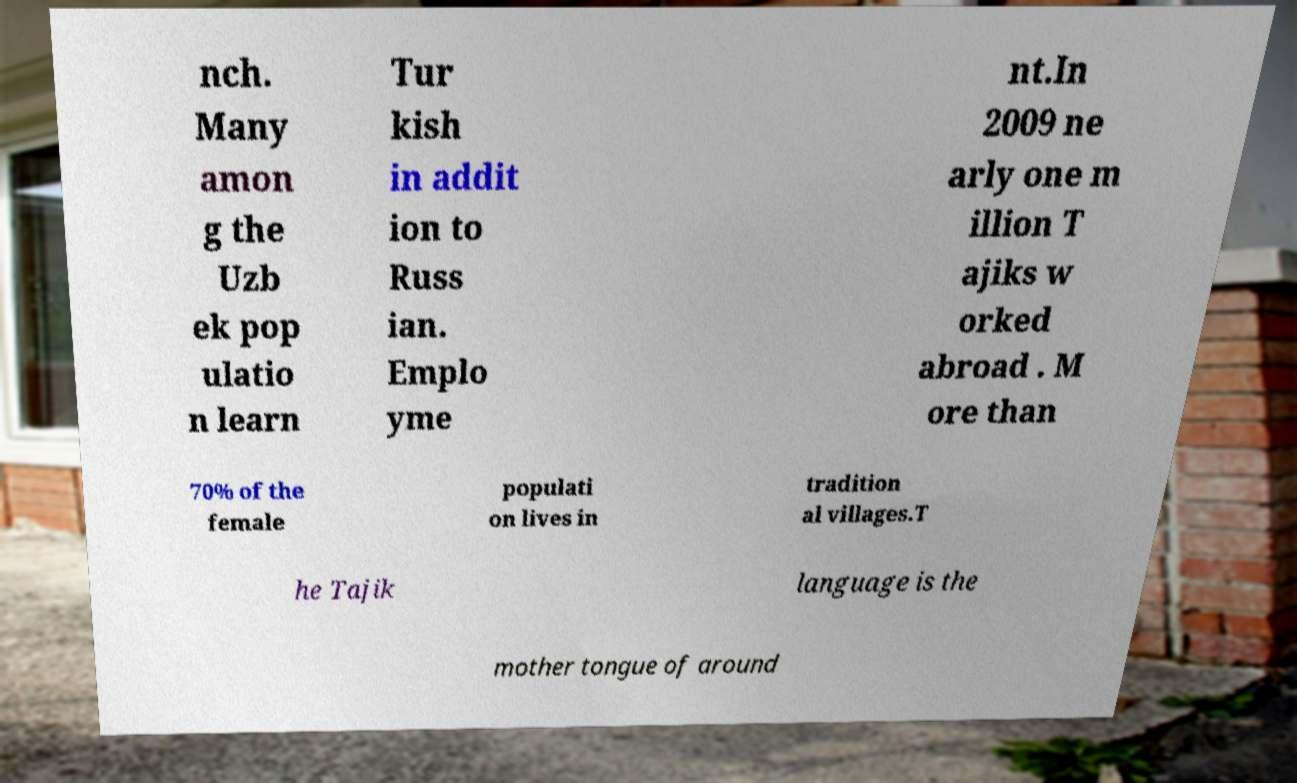There's text embedded in this image that I need extracted. Can you transcribe it verbatim? nch. Many amon g the Uzb ek pop ulatio n learn Tur kish in addit ion to Russ ian. Emplo yme nt.In 2009 ne arly one m illion T ajiks w orked abroad . M ore than 70% of the female populati on lives in tradition al villages.T he Tajik language is the mother tongue of around 